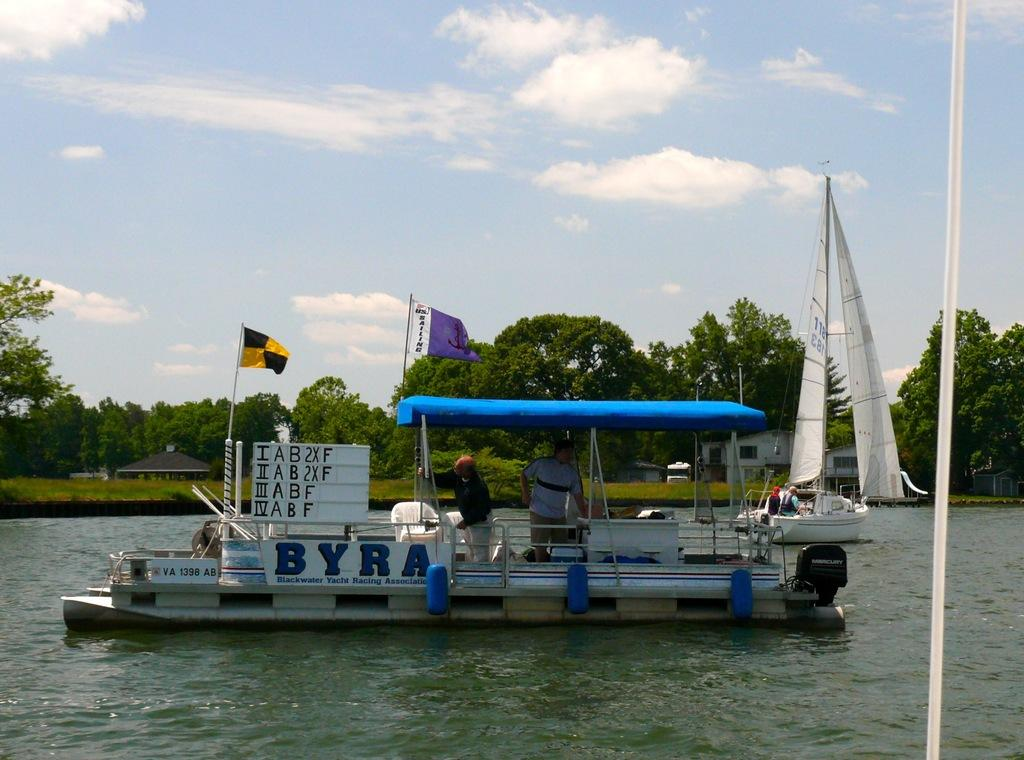<image>
Render a clear and concise summary of the photo. A pontoon boat with BYRA on the side is seen in the water. 